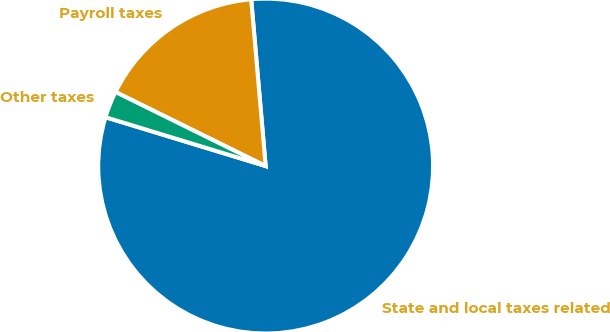<chart> <loc_0><loc_0><loc_500><loc_500><pie_chart><fcel>State and local taxes related<fcel>Payroll taxes<fcel>Other taxes<nl><fcel>81.09%<fcel>16.33%<fcel>2.58%<nl></chart> 